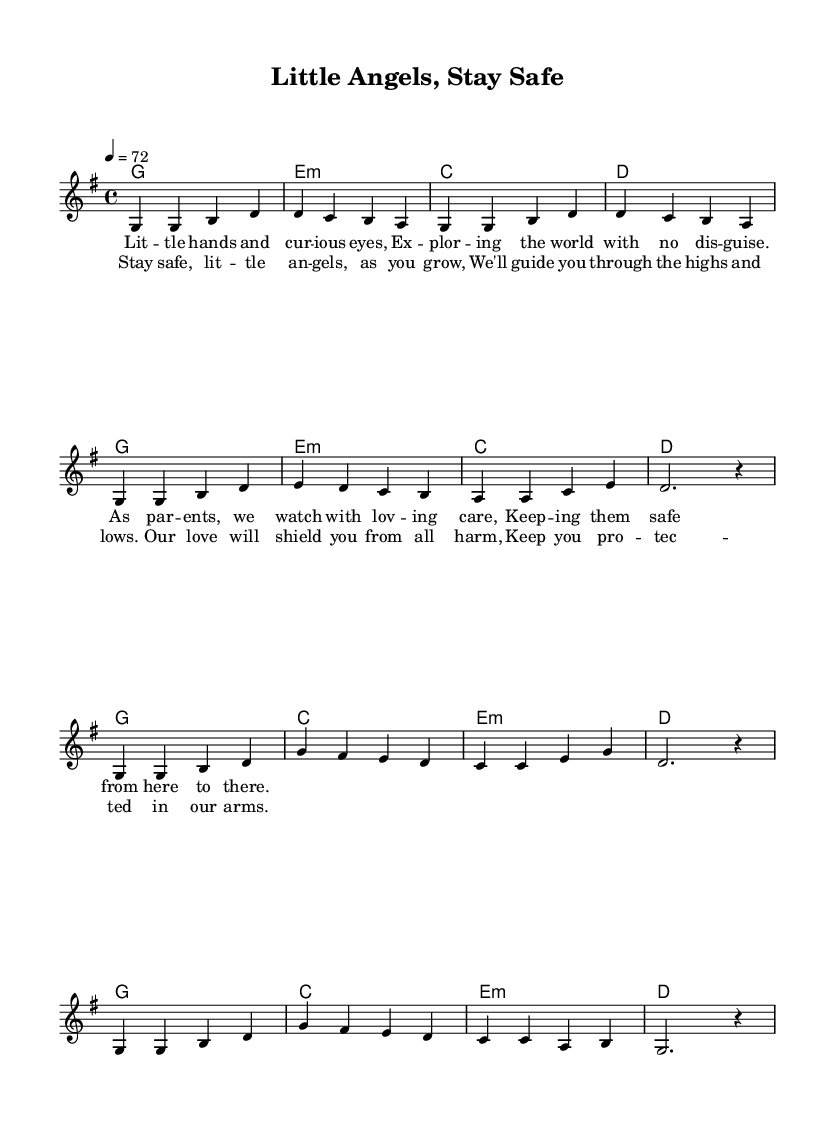What is the key signature of this music? The key signature indicates the notes that are sharp or flat throughout the piece. In this music, it shows one sharp, typical for G major, which affects the F note.
Answer: G major What is the time signature of this piece? The time signature is found at the beginning of the staff and it shows how many beats are in each measure. Here, it is 4/4, meaning there are four beats per measure.
Answer: 4/4 What is the tempo marking? The tempo marking sets the speed of the music, which is indicated at the start. In this score, it states "4 = 72," which means there are 72 quarter notes per minute.
Answer: 72 How many measures are in the verse section? To determine the number of measures in the verse, we can count the segments within the verse part of the score. The verse consists of 8 measures.
Answer: 8 What is the primary theme conveyed by the lyrics? The lyrics speak to parental concerns over child safety and well-being. They portray a nurturing and protective sentiment towards children, emphasizing love and guidance.
Answer: Child safety What chord is used in the chorus as the first chord? By examining the first chord in the chorus section of the score, we see that it is represented by a G major chord, which begins the emotional plea of the chorus.
Answer: G In what style is this music primarily composed? The song reflects traditional elements of country music, especially through its lyrical theme of parental care and emotional ballad structure, focusing on storytelling.
Answer: Country 